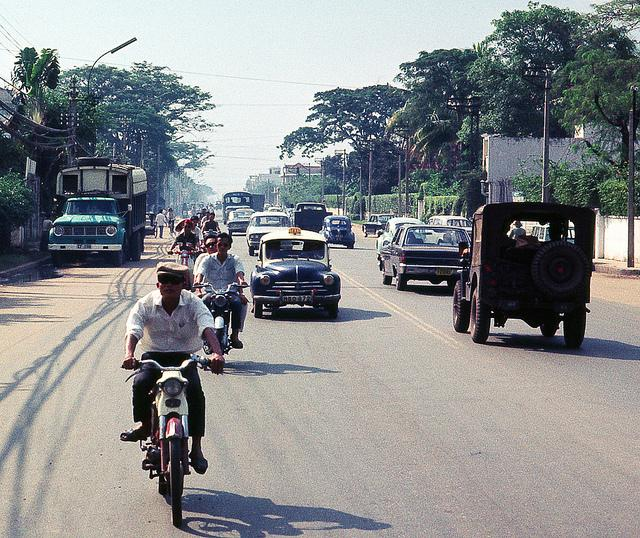What are is the image from? street 